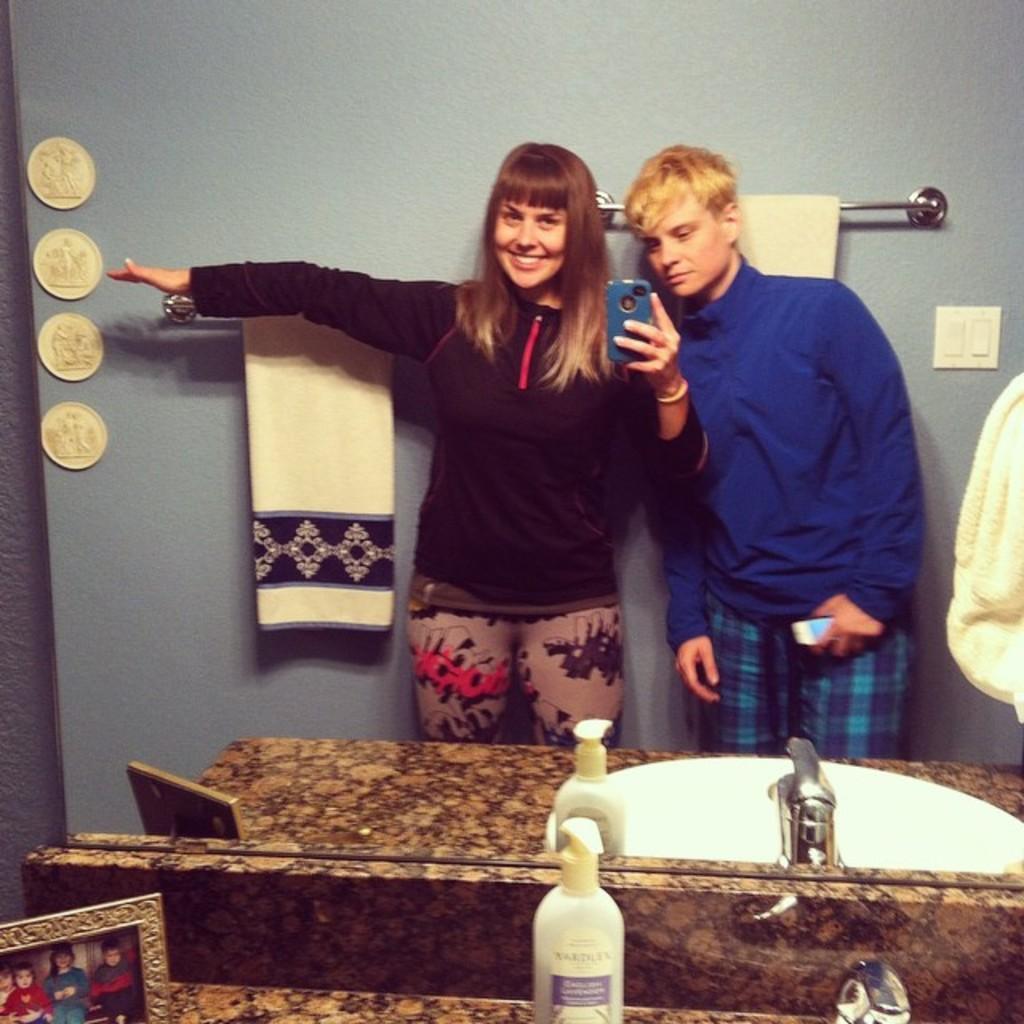Describe this image in one or two sentences. In this image we can see a man and woman is standing. Man is wearing blue color t-shirt and holding mobile in his hand. The woman is wearing black color t-shirt and holding mobile in her hand. Bottom of the image sink, photo frame and bottle is there. Background of the image the wall is in grey color and we can see towels. Right side of the image switch board is there. 